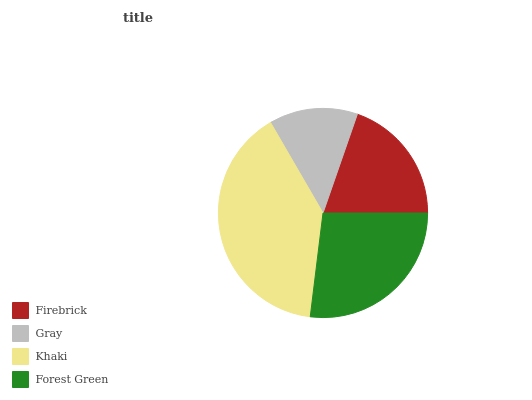Is Gray the minimum?
Answer yes or no. Yes. Is Khaki the maximum?
Answer yes or no. Yes. Is Khaki the minimum?
Answer yes or no. No. Is Gray the maximum?
Answer yes or no. No. Is Khaki greater than Gray?
Answer yes or no. Yes. Is Gray less than Khaki?
Answer yes or no. Yes. Is Gray greater than Khaki?
Answer yes or no. No. Is Khaki less than Gray?
Answer yes or no. No. Is Forest Green the high median?
Answer yes or no. Yes. Is Firebrick the low median?
Answer yes or no. Yes. Is Khaki the high median?
Answer yes or no. No. Is Gray the low median?
Answer yes or no. No. 